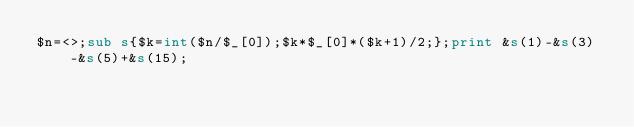<code> <loc_0><loc_0><loc_500><loc_500><_Perl_>$n=<>;sub s{$k=int($n/$_[0]);$k*$_[0]*($k+1)/2;};print &s(1)-&s(3)-&s(5)+&s(15);</code> 